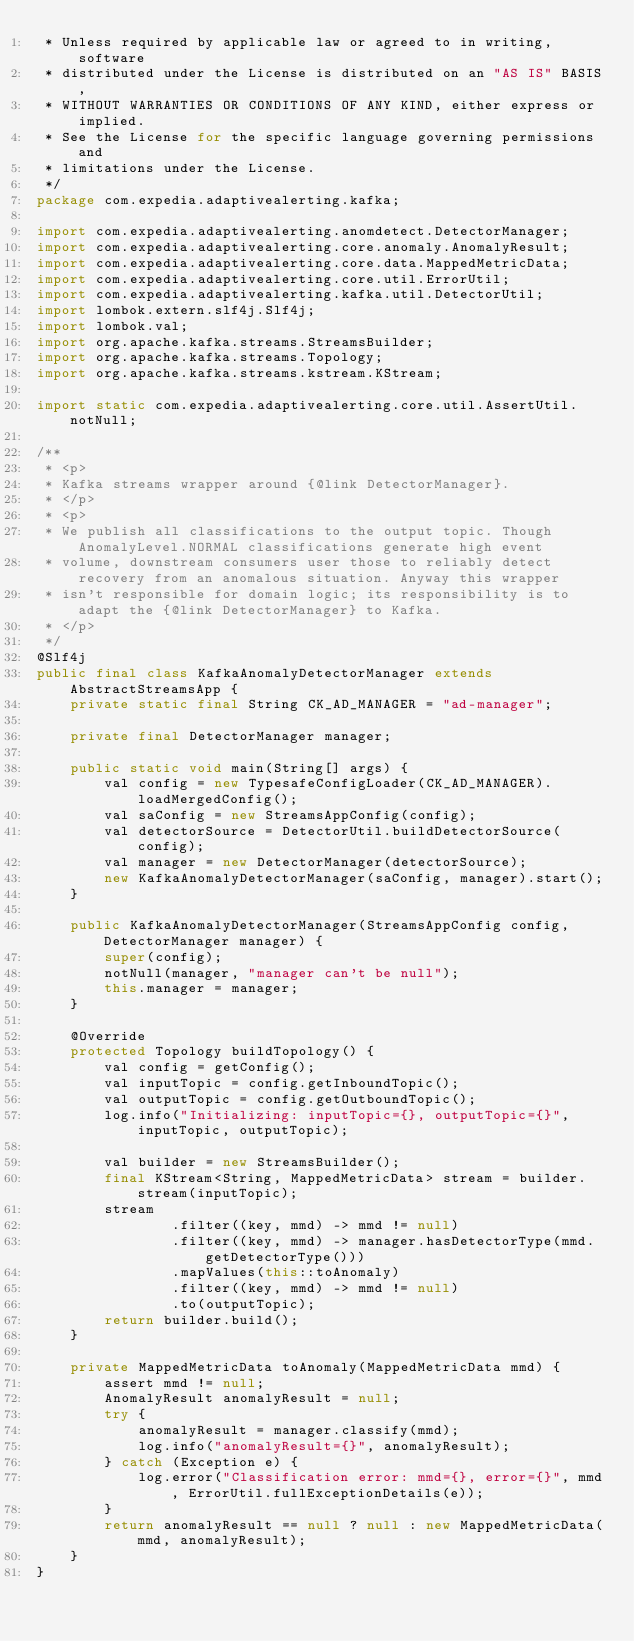<code> <loc_0><loc_0><loc_500><loc_500><_Java_> * Unless required by applicable law or agreed to in writing, software
 * distributed under the License is distributed on an "AS IS" BASIS,
 * WITHOUT WARRANTIES OR CONDITIONS OF ANY KIND, either express or implied.
 * See the License for the specific language governing permissions and
 * limitations under the License.
 */
package com.expedia.adaptivealerting.kafka;

import com.expedia.adaptivealerting.anomdetect.DetectorManager;
import com.expedia.adaptivealerting.core.anomaly.AnomalyResult;
import com.expedia.adaptivealerting.core.data.MappedMetricData;
import com.expedia.adaptivealerting.core.util.ErrorUtil;
import com.expedia.adaptivealerting.kafka.util.DetectorUtil;
import lombok.extern.slf4j.Slf4j;
import lombok.val;
import org.apache.kafka.streams.StreamsBuilder;
import org.apache.kafka.streams.Topology;
import org.apache.kafka.streams.kstream.KStream;

import static com.expedia.adaptivealerting.core.util.AssertUtil.notNull;

/**
 * <p>
 * Kafka streams wrapper around {@link DetectorManager}.
 * </p>
 * <p>
 * We publish all classifications to the output topic. Though AnomalyLevel.NORMAL classifications generate high event
 * volume, downstream consumers user those to reliably detect recovery from an anomalous situation. Anyway this wrapper
 * isn't responsible for domain logic; its responsibility is to adapt the {@link DetectorManager} to Kafka.
 * </p>
 */
@Slf4j
public final class KafkaAnomalyDetectorManager extends AbstractStreamsApp {
    private static final String CK_AD_MANAGER = "ad-manager";
    
    private final DetectorManager manager;
    
    public static void main(String[] args) {
        val config = new TypesafeConfigLoader(CK_AD_MANAGER).loadMergedConfig();
        val saConfig = new StreamsAppConfig(config);
        val detectorSource = DetectorUtil.buildDetectorSource(config);
        val manager = new DetectorManager(detectorSource);
        new KafkaAnomalyDetectorManager(saConfig, manager).start();
    }
    
    public KafkaAnomalyDetectorManager(StreamsAppConfig config, DetectorManager manager) {
        super(config);
        notNull(manager, "manager can't be null");
        this.manager = manager;
    }
    
    @Override
    protected Topology buildTopology() {
        val config = getConfig();
        val inputTopic = config.getInboundTopic();
        val outputTopic = config.getOutboundTopic();
        log.info("Initializing: inputTopic={}, outputTopic={}", inputTopic, outputTopic);
        
        val builder = new StreamsBuilder();
        final KStream<String, MappedMetricData> stream = builder.stream(inputTopic);
        stream
                .filter((key, mmd) -> mmd != null)
                .filter((key, mmd) -> manager.hasDetectorType(mmd.getDetectorType()))
                .mapValues(this::toAnomaly)
                .filter((key, mmd) -> mmd != null)
                .to(outputTopic);
        return builder.build();
    }
    
    private MappedMetricData toAnomaly(MappedMetricData mmd) {
        assert mmd != null;
        AnomalyResult anomalyResult = null;
        try {
            anomalyResult = manager.classify(mmd);
            log.info("anomalyResult={}", anomalyResult);
        } catch (Exception e) {
            log.error("Classification error: mmd={}, error={}", mmd, ErrorUtil.fullExceptionDetails(e));
        }
        return anomalyResult == null ? null : new MappedMetricData(mmd, anomalyResult);
    }
}
</code> 